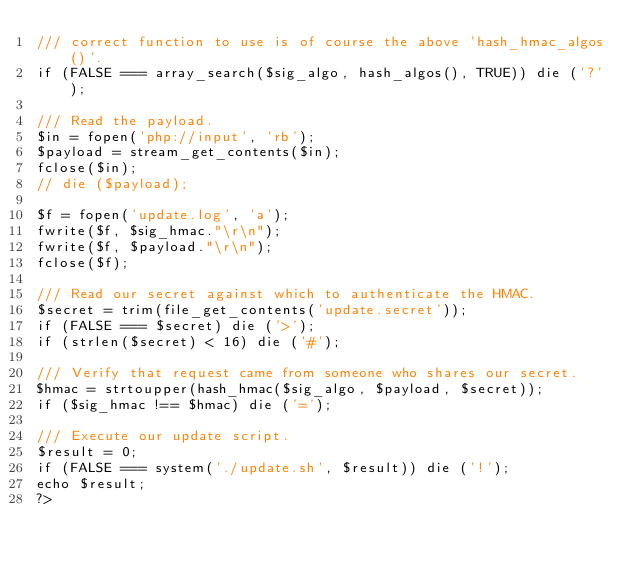Convert code to text. <code><loc_0><loc_0><loc_500><loc_500><_PHP_>/// correct function to use is of course the above 'hash_hmac_algos()'.
if (FALSE === array_search($sig_algo, hash_algos(), TRUE)) die ('?');

/// Read the payload.
$in = fopen('php://input', 'rb');
$payload = stream_get_contents($in);
fclose($in);
// die ($payload);

$f = fopen('update.log', 'a');
fwrite($f, $sig_hmac."\r\n");
fwrite($f, $payload."\r\n");
fclose($f);

/// Read our secret against which to authenticate the HMAC.
$secret = trim(file_get_contents('update.secret'));
if (FALSE === $secret) die ('>');
if (strlen($secret) < 16) die ('#');

/// Verify that request came from someone who shares our secret.
$hmac = strtoupper(hash_hmac($sig_algo, $payload, $secret));
if ($sig_hmac !== $hmac) die ('=');

/// Execute our update script.
$result = 0;
if (FALSE === system('./update.sh', $result)) die ('!');
echo $result;
?></code> 